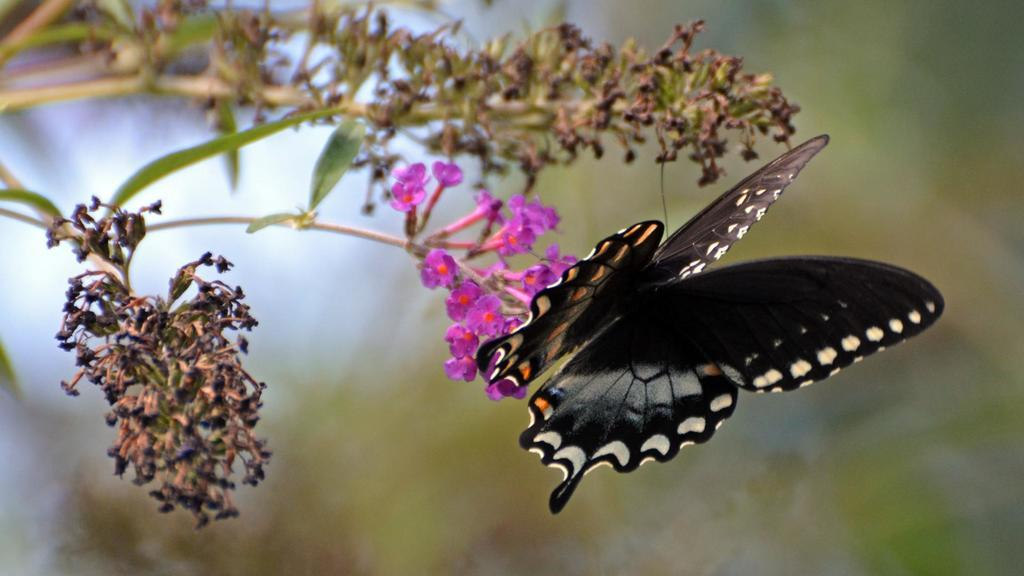What is the main subject of the image? There is a butterfly in the image. What is the butterfly doing in the image? The butterfly is on a pink flower. What can be seen on the left side of the image? There is a plant on the left side of the image. How would you describe the background of the image? The backdrop of the image is blurred. What color is the butterfly in the image? The butterfly is black in color. What type of shame is depicted in the image? There is no depiction of shame in the image; it features a butterfly on a pink flower. What type of war is taking place in the image? There is no war depicted in the image; it features a butterfly on a pink flower. 